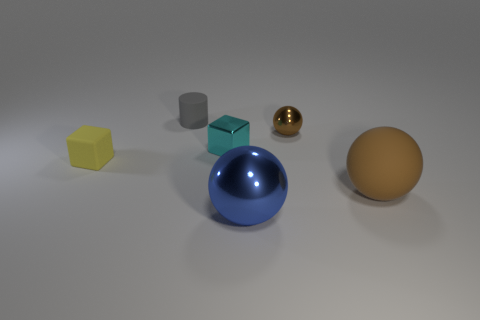How many objects are brown objects behind the tiny yellow matte block or tiny cubes that are in front of the cyan thing?
Your answer should be very brief. 2. How many other objects are the same shape as the large metallic thing?
Provide a short and direct response. 2. Do the sphere that is in front of the brown rubber ball and the rubber cylinder have the same color?
Provide a succinct answer. No. How many other things are the same size as the matte cylinder?
Provide a succinct answer. 3. Is the material of the yellow block the same as the small cyan thing?
Offer a very short reply. No. The big ball left of the rubber thing to the right of the large blue ball is what color?
Offer a terse response. Blue. What size is the blue metallic object that is the same shape as the tiny brown thing?
Offer a terse response. Large. Is the color of the rubber ball the same as the tiny sphere?
Provide a succinct answer. Yes. How many brown shiny spheres are on the right side of the brown ball that is to the right of the brown thing that is left of the large brown object?
Make the answer very short. 0. Is the number of tiny shiny cylinders greater than the number of gray matte things?
Your response must be concise. No. 